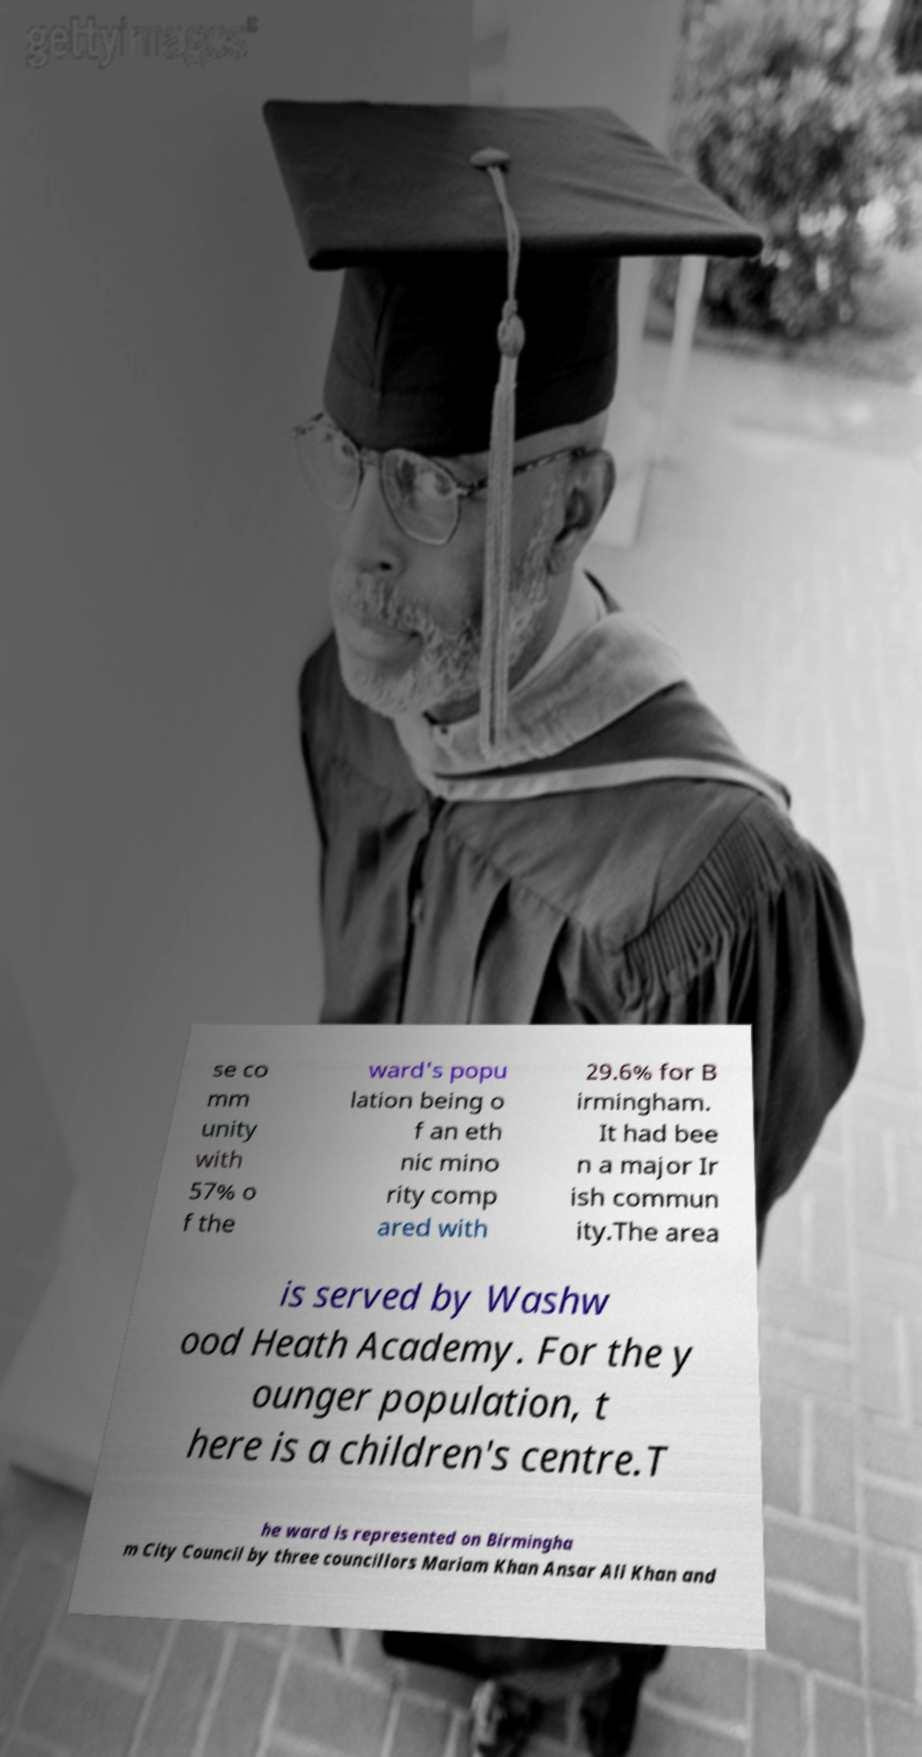For documentation purposes, I need the text within this image transcribed. Could you provide that? se co mm unity with 57% o f the ward's popu lation being o f an eth nic mino rity comp ared with 29.6% for B irmingham. It had bee n a major Ir ish commun ity.The area is served by Washw ood Heath Academy. For the y ounger population, t here is a children's centre.T he ward is represented on Birmingha m City Council by three councillors Mariam Khan Ansar Ali Khan and 